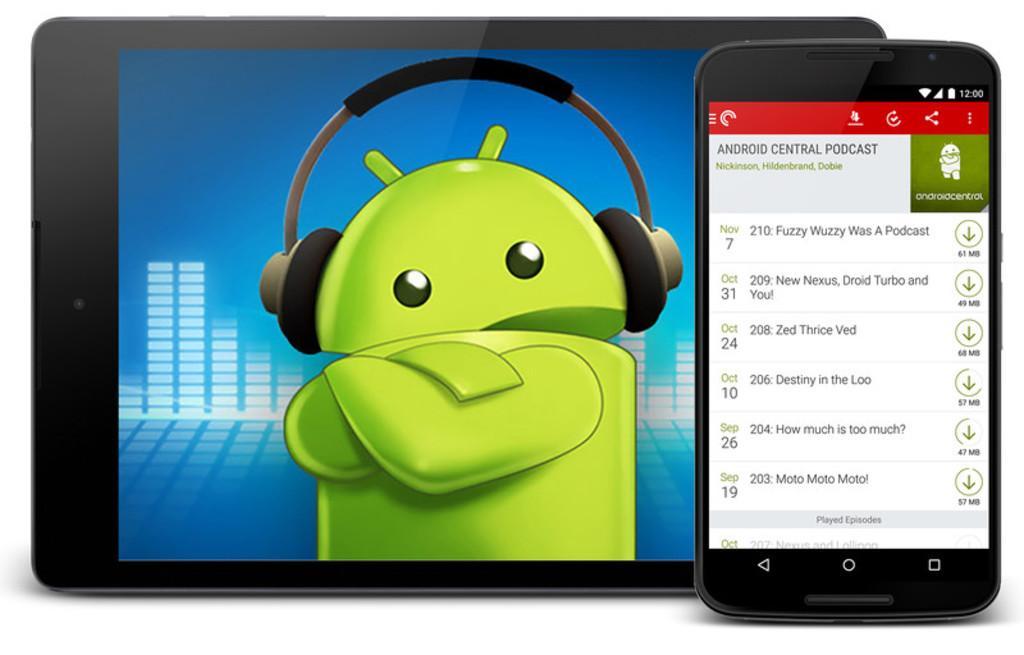Can you describe this image briefly? In this image I see the depiction of a tab and a phone and I see a cartoon character over here which is of green in color and I see something is written on this phone and I see the white color background. 